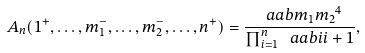<formula> <loc_0><loc_0><loc_500><loc_500>A _ { n } ( 1 ^ { + } , \dots , m _ { 1 } ^ { - } , \dots , m _ { 2 } ^ { - } , \dots , n ^ { + } ) = \frac { \ a a b { m _ { 1 } } { m _ { 2 } } ^ { 4 } } { \prod _ { i = 1 } ^ { n } \ a a b { i } { i + 1 } } ,</formula> 